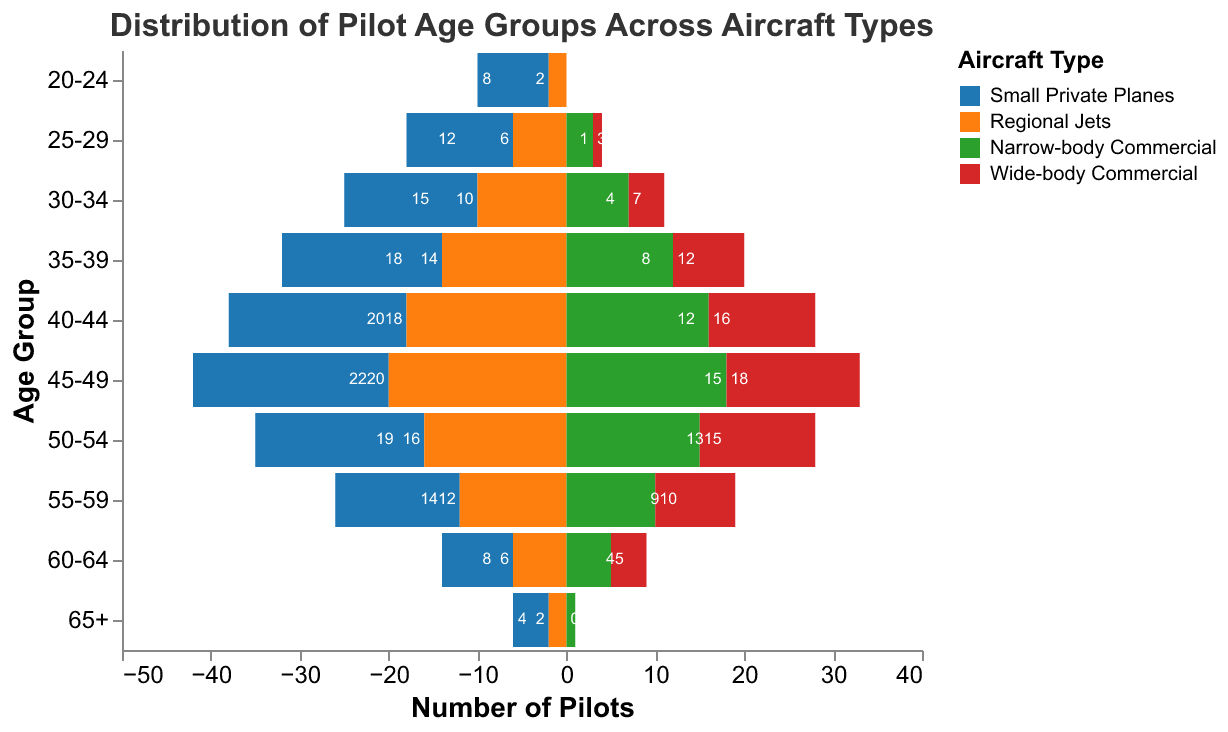What's the title of the figure? The title is displayed at the top of the figure. It reads: "Distribution of Pilot Age Groups Across Aircraft Types".
Answer: Distribution of Pilot Age Groups Across Aircraft Types Which age group has the highest number of pilots for small private planes? By analyzing the data, the age group "45-49" has a higher count of pilots, showing 22 pilots in the chart.
Answer: 45-49 How many pilots aged 25-29 fly wide-body commercial aircraft? The figure shows the number of pilots in each age group and aircraft type. For pilots aged 25-29 flying wide-body commercial, the number is 1.
Answer: 1 What is the difference in the number of pilots aged 40-44 between small private planes and narrow-body commercial aircraft? From the data, the count for the age group 40-44 is 20 for small private planes and 16 for narrow-body commercial aircraft. The difference is 20 - 16 = 4.
Answer: 4 What is the total number of pilots aged 60-64 for all aircraft types? Adding up the pilots in the age group 60-64 across all types: 8 (Small Private Planes) + 6 (Regional Jets) + 5 (Narrow-body Commercial) + 4 (Wide-body Commercial) = 23.
Answer: 23 Which aircraft type has the fewest number of pilots in the age group 65+? The figure reveals that wide-body commercial has the fewest, with 0 pilots in the age group 65+.
Answer: Wide-body Commercial In which aircraft type do pilots aged 30-34 outnumber pilots aged 35-39, and by how much? Analyzing the figure, small private planes have 15 pilots aged 30-34 compared to 18 aged 35-39. Therefore, the outnumbered count is 18 - 15 = 3. So, none. Regional jets, narrow-body, or wide-body commercial do not satisfy this condition.
Answer: None What is the total number of pilots flying narrow-body commercial aircraft? Summing up narrow-body commercial pilots across all age groups: 0 + 3 + 7 + 12 + 16 + 18 + 15 + 10 + 5 + 1 = 87.
Answer: 87 Do small private planes have more pilots aged 55-59 compared to those aged 20-24? Small private planes have 14 pilots aged 55-59 and 8 pilots aged 20-24, so yes.
Answer: Yes 